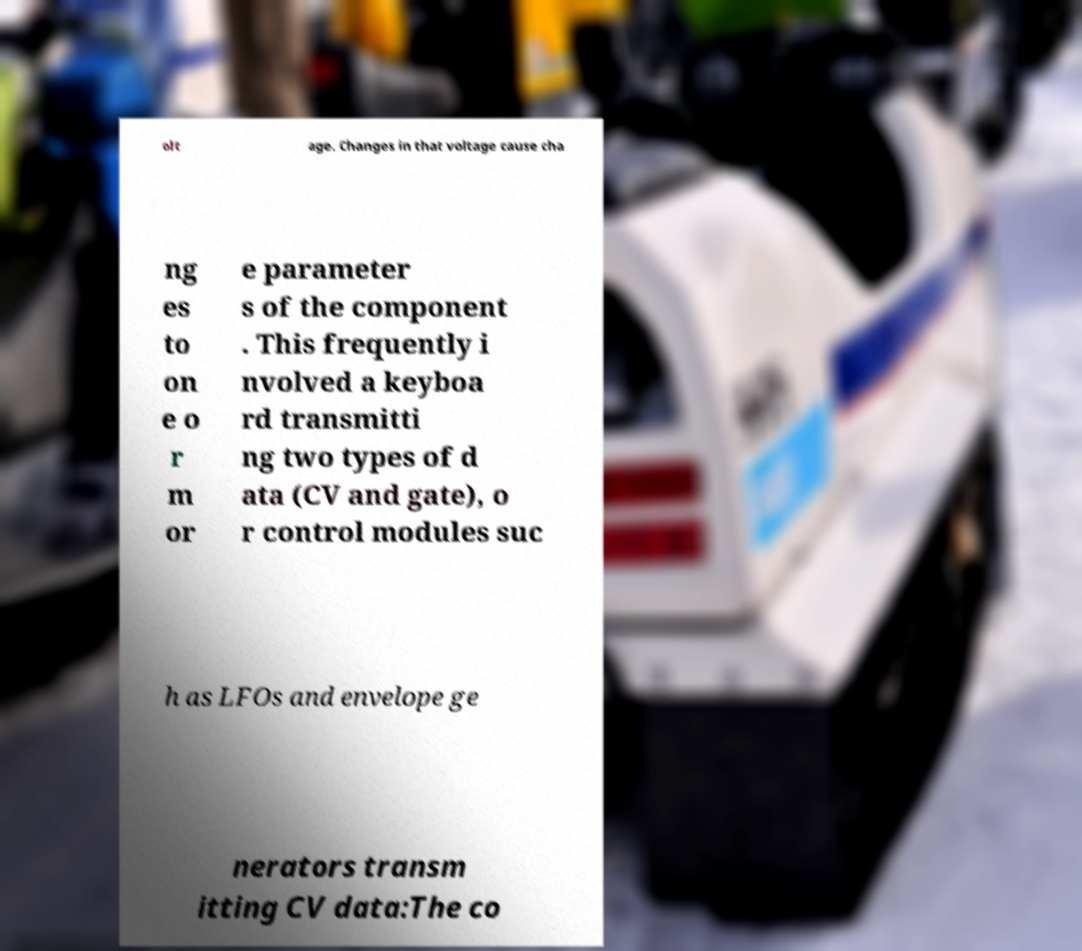What messages or text are displayed in this image? I need them in a readable, typed format. olt age. Changes in that voltage cause cha ng es to on e o r m or e parameter s of the component . This frequently i nvolved a keyboa rd transmitti ng two types of d ata (CV and gate), o r control modules suc h as LFOs and envelope ge nerators transm itting CV data:The co 